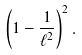<formula> <loc_0><loc_0><loc_500><loc_500>\left ( 1 - \frac { 1 } { \ell ^ { 2 } } \right ) ^ { 2 } .</formula> 